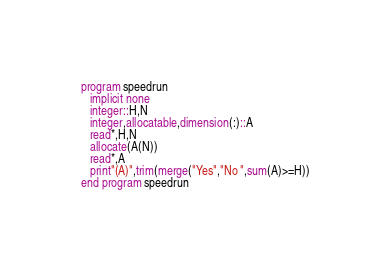Convert code to text. <code><loc_0><loc_0><loc_500><loc_500><_FORTRAN_>program speedrun
   implicit none
   integer::H,N
   integer,allocatable,dimension(:)::A
   read*,H,N
   allocate(A(N))
   read*,A
   print"(A)",trim(merge("Yes","No ",sum(A)>=H))
end program speedrun</code> 